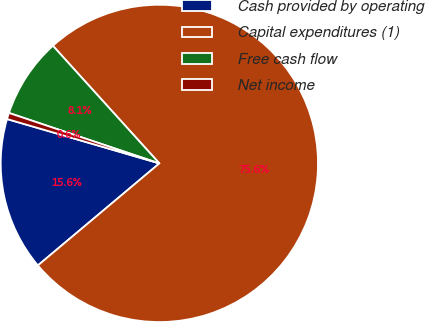Convert chart to OTSL. <chart><loc_0><loc_0><loc_500><loc_500><pie_chart><fcel>Cash provided by operating<fcel>Capital expenditures (1)<fcel>Free cash flow<fcel>Net income<nl><fcel>15.63%<fcel>75.59%<fcel>8.14%<fcel>0.64%<nl></chart> 